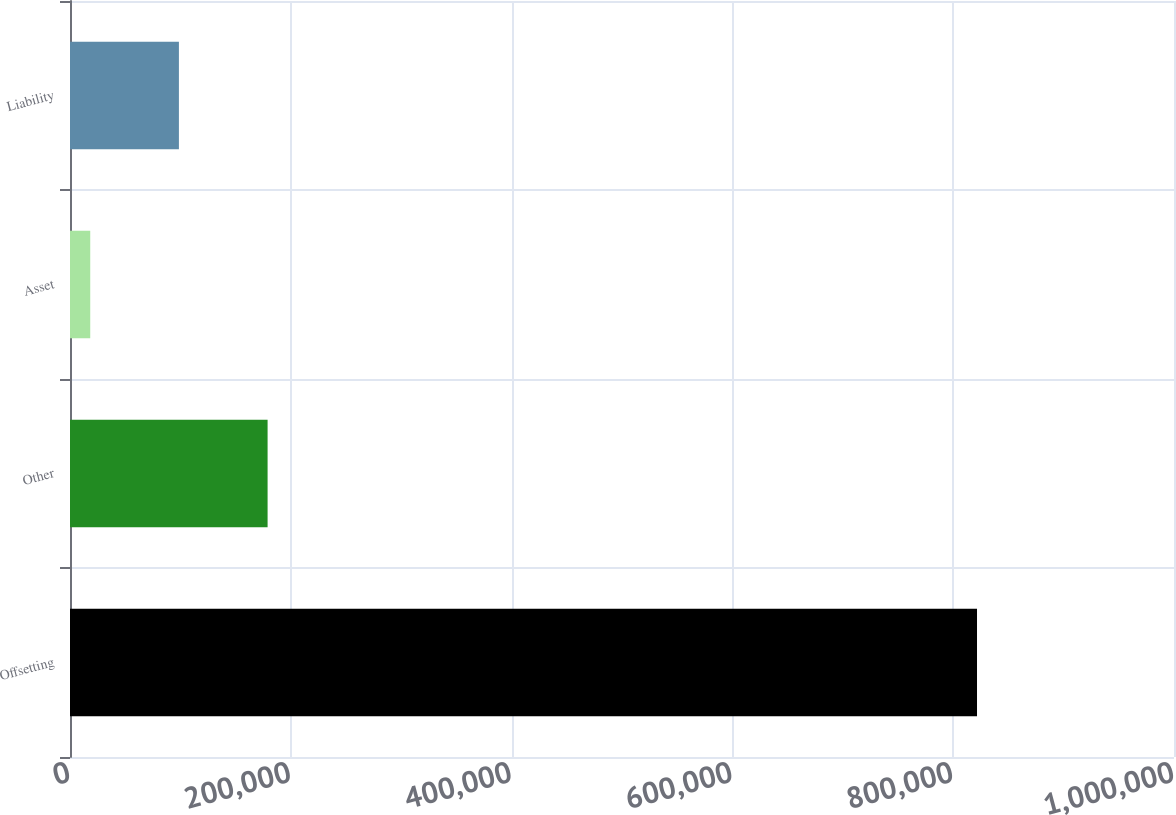Convert chart. <chart><loc_0><loc_0><loc_500><loc_500><bar_chart><fcel>Offsetting<fcel>Other<fcel>Asset<fcel>Liability<nl><fcel>821571<fcel>178980<fcel>18332<fcel>98655.9<nl></chart> 